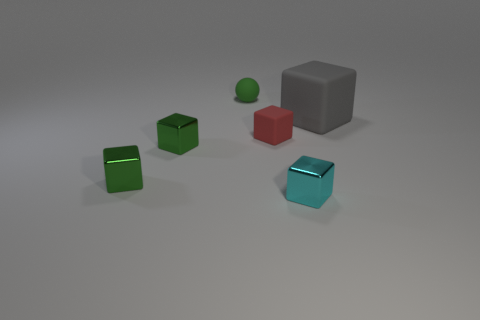What number of yellow things are tiny blocks or matte blocks?
Offer a very short reply. 0. Is the shape of the green matte thing the same as the tiny red matte object?
Your response must be concise. No. There is a rubber cube that is in front of the large gray rubber block; is there a red block that is on the left side of it?
Provide a succinct answer. No. Are there an equal number of large gray matte blocks in front of the big gray thing and blue things?
Keep it short and to the point. Yes. What number of other objects are there of the same size as the cyan metallic cube?
Keep it short and to the point. 4. Are the thing right of the small cyan metallic cube and the tiny green thing that is behind the big rubber object made of the same material?
Ensure brevity in your answer.  Yes. How big is the matte block on the left side of the metal cube on the right side of the small green matte ball?
Your answer should be very brief. Small. Are there any small metallic balls that have the same color as the big cube?
Provide a short and direct response. No. There is a rubber thing that is right of the red cube; does it have the same color as the tiny rubber thing on the right side of the small green rubber object?
Offer a terse response. No. What shape is the small green rubber object?
Give a very brief answer. Sphere. 